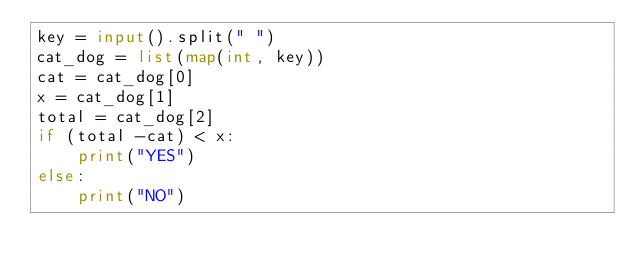<code> <loc_0><loc_0><loc_500><loc_500><_Python_>key = input().split(" ")
cat_dog = list(map(int, key))
cat = cat_dog[0]
x = cat_dog[1]
total = cat_dog[2]
if (total -cat) < x:
    print("YES")
else:
    print("NO")




</code> 